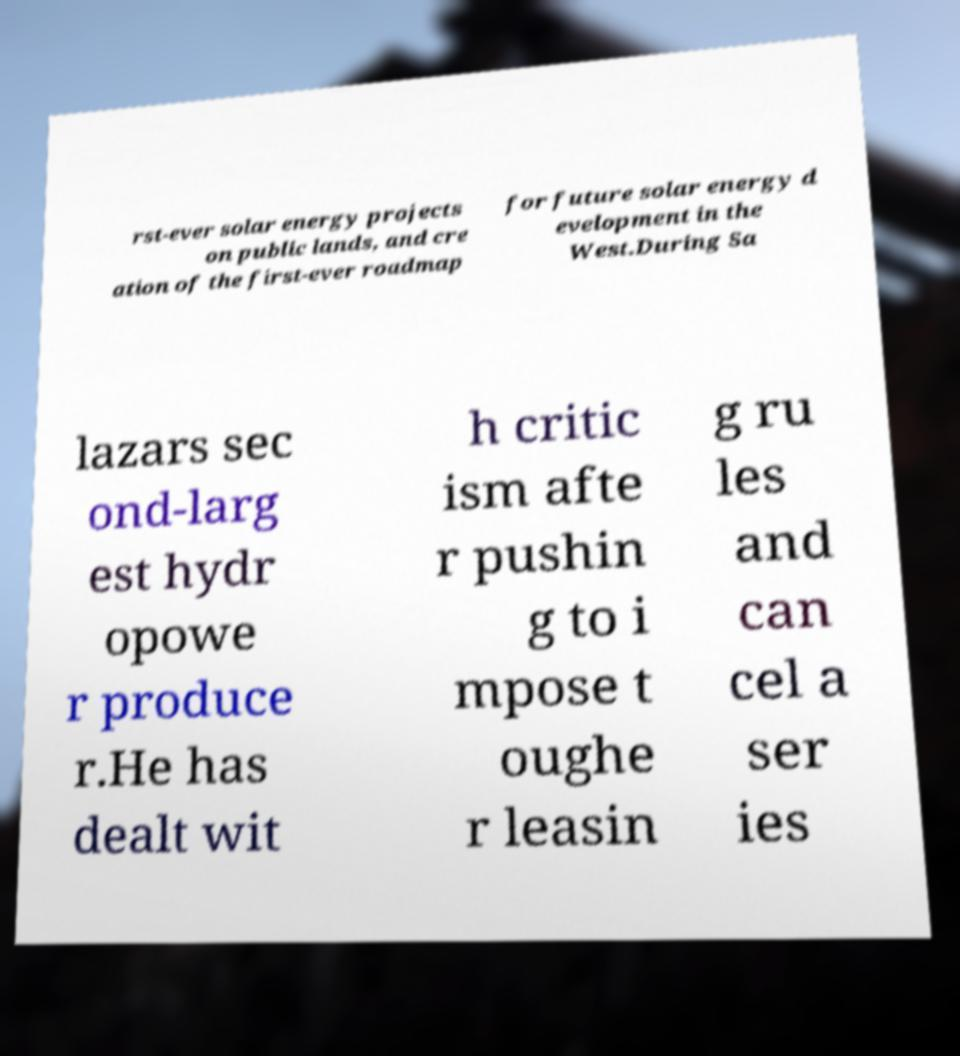Can you accurately transcribe the text from the provided image for me? rst-ever solar energy projects on public lands, and cre ation of the first-ever roadmap for future solar energy d evelopment in the West.During Sa lazars sec ond-larg est hydr opowe r produce r.He has dealt wit h critic ism afte r pushin g to i mpose t oughe r leasin g ru les and can cel a ser ies 